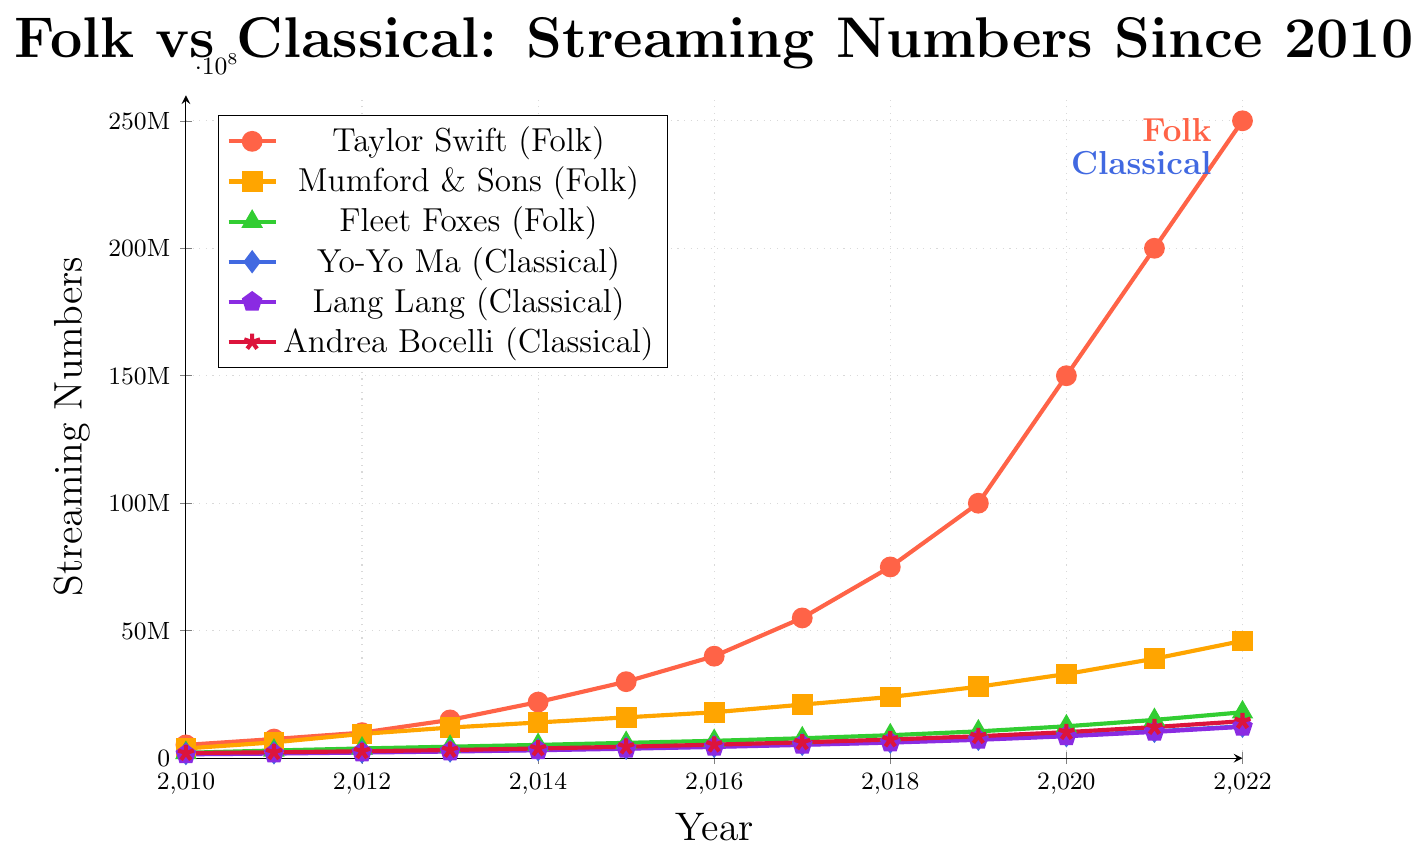Which folk artist had the highest streaming numbers in 2012? Look at the data points for 2012 and identify which folk artist has the highest elevation. Taylor Swift shows the highest streaming numbers in this year.
Answer: Taylor Swift Which classical artist saw the greatest increase in streaming numbers from 2017 to 2018? Compare the difference in streaming numbers between 2017 and 2018 for all classical artists. Yo-Yo Ma increased from 5,400,000 to 6,300,000, Lang Lang from 5,200,000 to 6,100,000, and Andrea Bocelli from 6,200,000 to 7,300,000. Andrea Bocelli had the greatest increase.
Answer: Andrea Bocelli What are the total streaming numbers for all folk artists in 2015? Sum the streaming numbers for Taylor Swift, Mumford & Sons, and Fleet Foxes in 2015: 30,000,000 + 16,000,000 + 6,000,000 = 52,000,000.
Answer: 52,000,000 Between 2010 and 2022, by how much did Yo-Yo Ma's streaming numbers increase? subtract Yo-Yo Ma's streaming numbers in 2010 from his numbers in 2022: 12,500,000 - 1,800,000 = 10,700,000.
Answer: 10,700,000 Who had higher streaming numbers in 2014, Fleet Foxes or Lang Lang? Compare the streaming numbers of Fleet Foxes and Lang Lang in 2014 on the figure. Fleet Foxes have 5,200,000 and Lang Lang has 3,100,000. Therefore, Fleet Foxes have higher streaming numbers.
Answer: Fleet Foxes What was the average increase in streaming numbers per year for Taylor Swift from 2010 to 2022? Calculate the total increase in Taylor Swift's streaming numbers from 2010 to 2022, which is 250,000,000 - 5,200,000 = 244,800,000. There are 12 intervals between these years, so the average increase per year is 244,800,000 / 12.
Answer: 20,400,000 Which genre had the higher total streaming numbers in 2020: folk or classical? Sum the streaming numbers for all folk artists and all classical artists in 2020. Folk: 150,000,000 + 33,000,000 + 12,500,000 = 195,500,000; Classical: 8,800,000 + 8,600,000 + 10,200,000 = 27,600,000. Folk has higher total streaming numbers.
Answer: Folk By what factor did streaming numbers for Mumford & Sons increase from 2010 to 2022? Divide the streaming numbers for Mumford & Sons in 2022 by the numbers in 2010: 46,000,000 / 3,800,000 = 12.1.
Answer: 12.1 